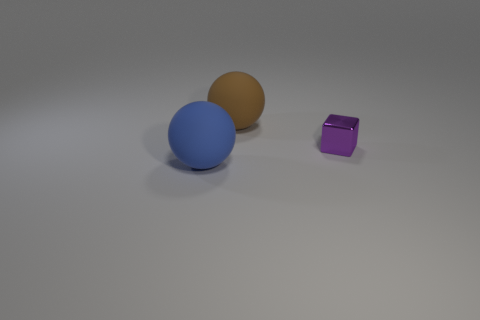Add 1 balls. How many objects exist? 4 Subtract 1 balls. How many balls are left? 1 Subtract all balls. How many objects are left? 1 Subtract all blue cylinders. Subtract all big brown rubber balls. How many objects are left? 2 Add 1 large blue balls. How many large blue balls are left? 2 Add 1 small shiny cubes. How many small shiny cubes exist? 2 Subtract 0 red cylinders. How many objects are left? 3 Subtract all green cubes. Subtract all red cylinders. How many cubes are left? 1 